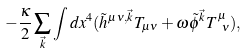<formula> <loc_0><loc_0><loc_500><loc_500>- \frac { \kappa } { 2 } \sum _ { \vec { k } } \int d x ^ { 4 } ( \tilde { h } ^ { \mu \nu , \vec { k } } T _ { \mu \nu } + \omega \tilde { \phi } ^ { \vec { k } } T ^ { \mu } _ { \ \nu } ) ,</formula> 